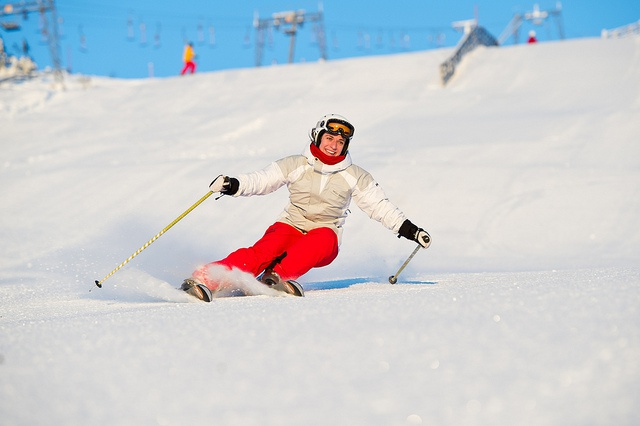Describe the objects in this image and their specific colors. I can see people in teal, lightgray, red, and tan tones, skis in teal, gray, black, and darkgray tones, people in teal, orange, brown, lightpink, and violet tones, and people in teal, violet, lightblue, brown, and lightgray tones in this image. 